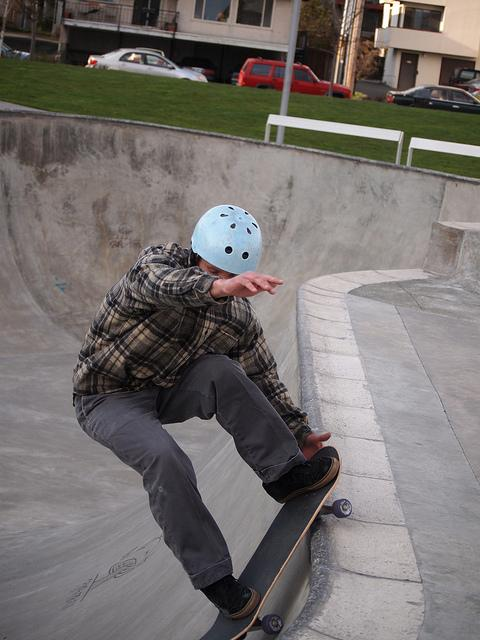Which group allegedly invented skateboards?

Choices:
A) scientists
B) football players
C) surfers
D) baseball fans surfers 